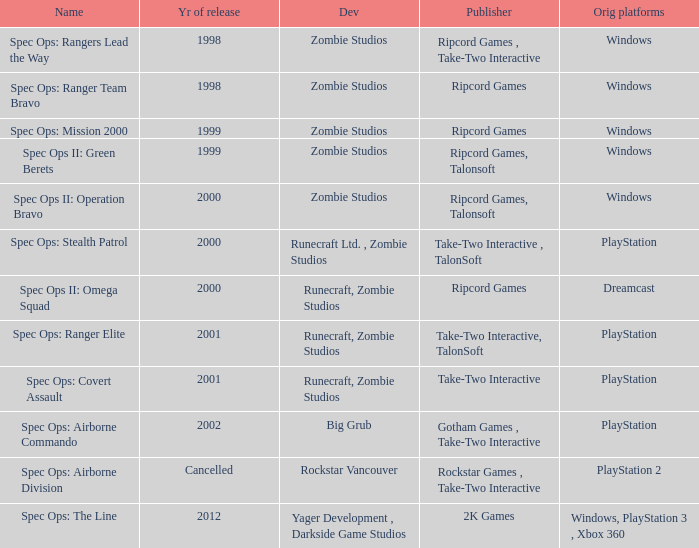Which publisher is responsible for spec ops: stealth patrol? Take-Two Interactive , TalonSoft. 